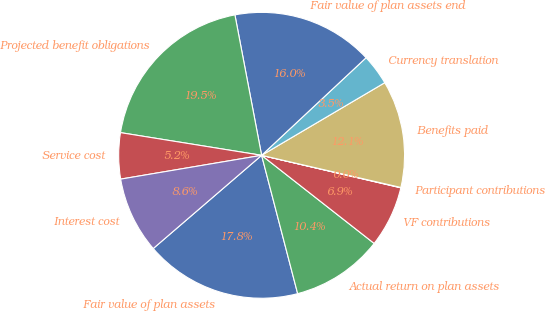Convert chart. <chart><loc_0><loc_0><loc_500><loc_500><pie_chart><fcel>Fair value of plan assets<fcel>Actual return on plan assets<fcel>VF contributions<fcel>Participant contributions<fcel>Benefits paid<fcel>Currency translation<fcel>Fair value of plan assets end<fcel>Projected benefit obligations<fcel>Service cost<fcel>Interest cost<nl><fcel>17.75%<fcel>10.37%<fcel>6.92%<fcel>0.04%<fcel>12.09%<fcel>3.48%<fcel>16.03%<fcel>19.47%<fcel>5.2%<fcel>8.64%<nl></chart> 